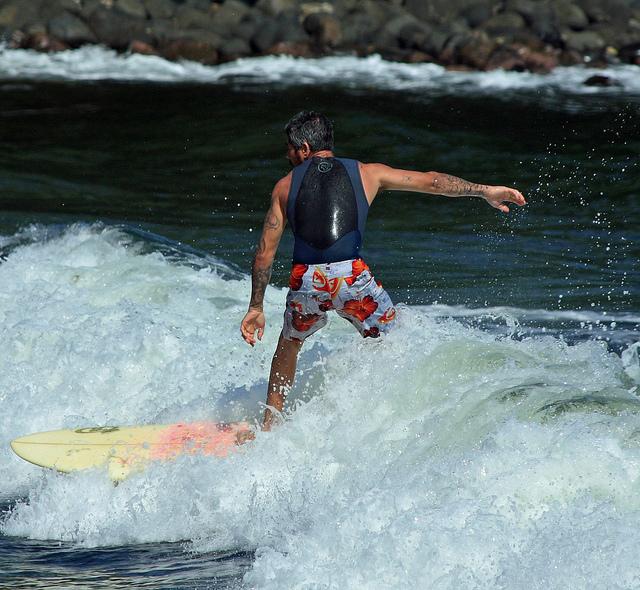What is the print on the men's swim trunks?
Quick response, please. Flowers. Is he upright?
Write a very short answer. Yes. What is the person doing?
Answer briefly. Surfing. Is this man falling off of his board?
Keep it brief. No. Does the surfer have visible tattoos?
Keep it brief. Yes. 